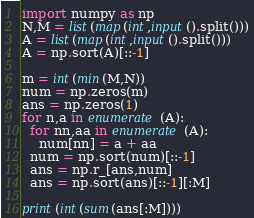Convert code to text. <code><loc_0><loc_0><loc_500><loc_500><_Python_>import numpy as np
N,M = list(map(int,input().split()))
A = list(map(int,input().split()))
A = np.sort(A)[::-1]
 
m = int(min(M,N))
num = np.zeros(m)
ans = np.zeros(1)
for n,a in enumerate(A):
  for nn,aa in enumerate(A):
    num[nn] = a + aa
  num = np.sort(num)[::-1]
  ans = np.r_[ans,num]
  ans = np.sort(ans)[::-1][:M]

print(int(sum(ans[:M])))</code> 